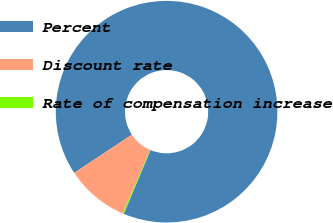Convert chart to OTSL. <chart><loc_0><loc_0><loc_500><loc_500><pie_chart><fcel>Percent<fcel>Discount rate<fcel>Rate of compensation increase<nl><fcel>90.64%<fcel>9.21%<fcel>0.16%<nl></chart> 